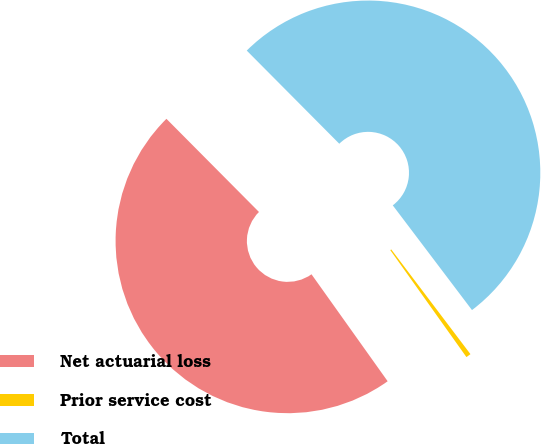Convert chart to OTSL. <chart><loc_0><loc_0><loc_500><loc_500><pie_chart><fcel>Net actuarial loss<fcel>Prior service cost<fcel>Total<nl><fcel>47.4%<fcel>0.46%<fcel>52.14%<nl></chart> 